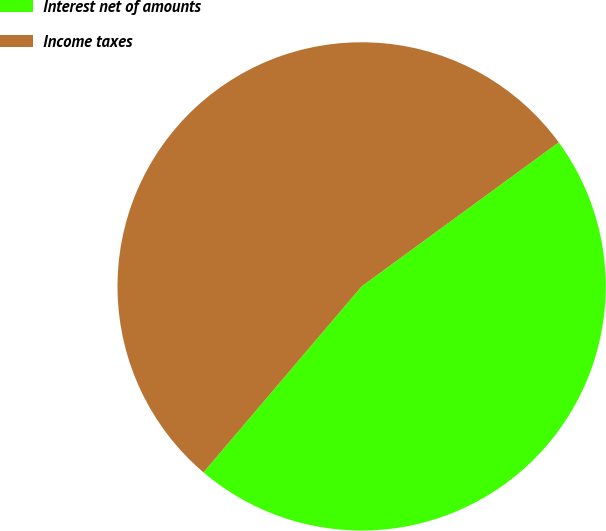Convert chart to OTSL. <chart><loc_0><loc_0><loc_500><loc_500><pie_chart><fcel>Interest net of amounts<fcel>Income taxes<nl><fcel>46.26%<fcel>53.74%<nl></chart> 